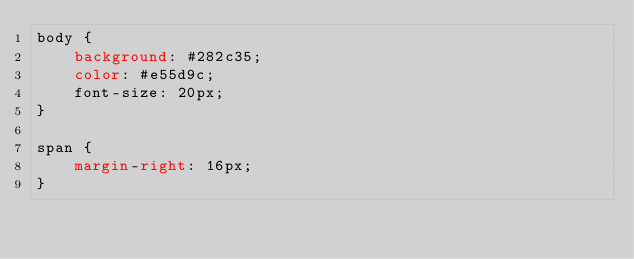<code> <loc_0><loc_0><loc_500><loc_500><_CSS_>body {
    background: #282c35;
    color: #e55d9c;
    font-size: 20px;
}

span {
    margin-right: 16px;
}
</code> 